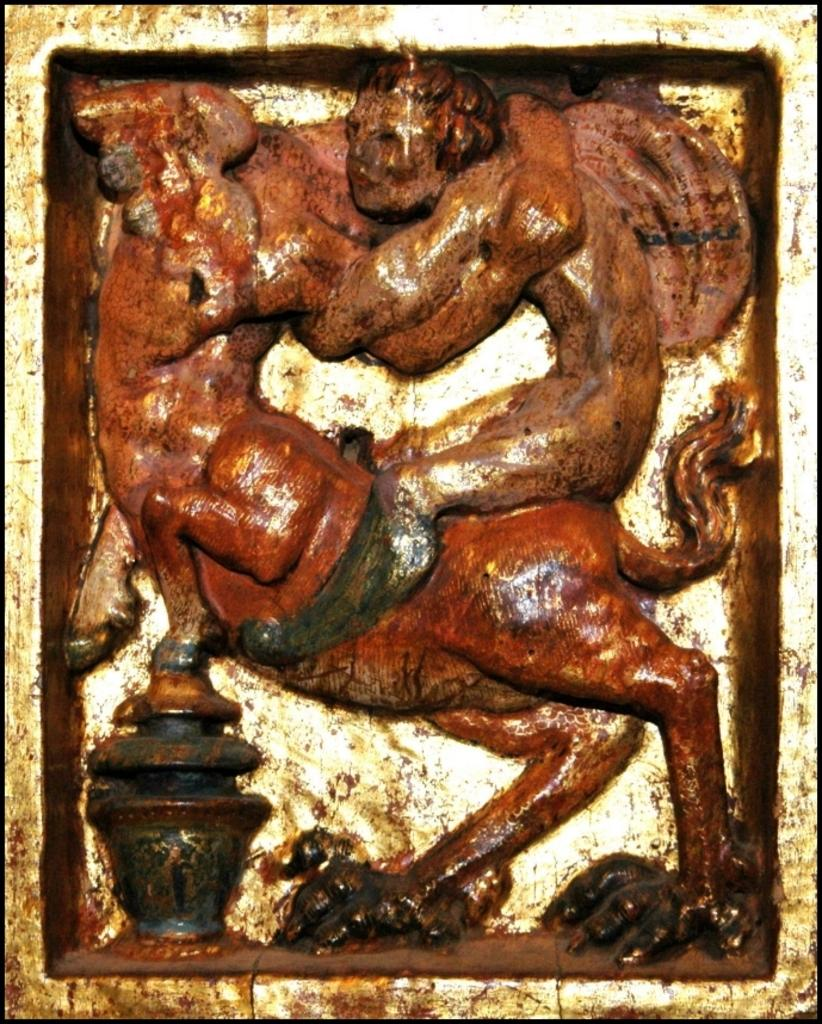What is the main subject of the image? There is a sculpture in the image. How does the sculpture attack the viewer in the image? The sculpture does not attack the viewer in the image, as sculptures are inanimate objects and cannot perform actions like attacking. 